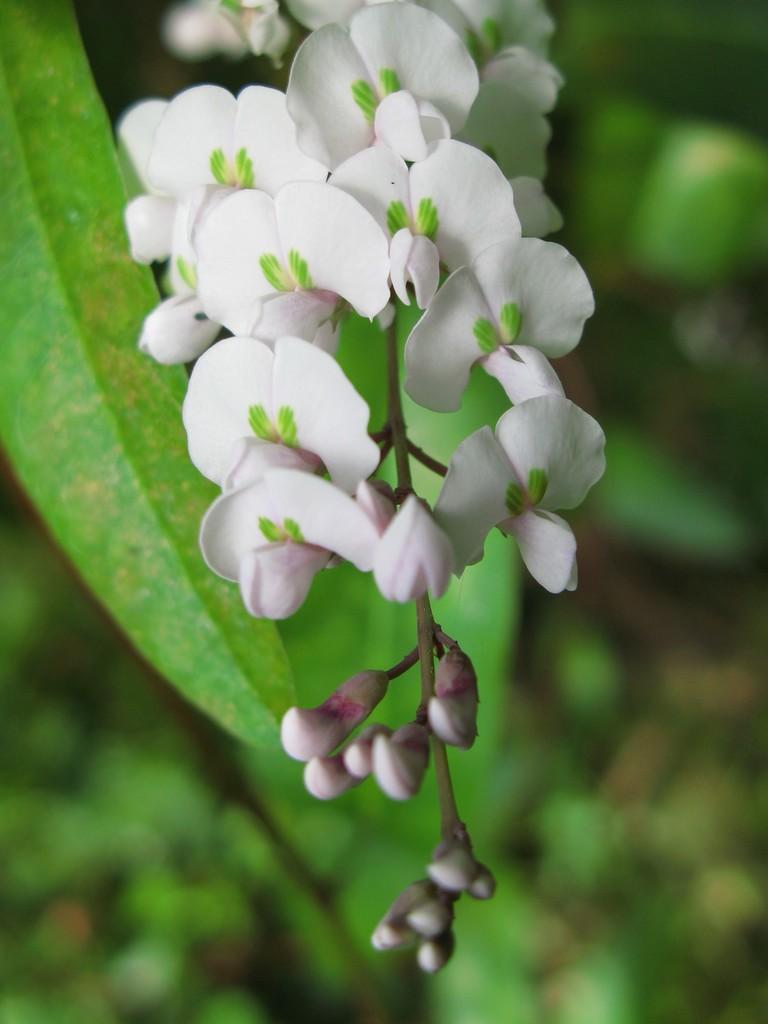Can you describe this image briefly? In this image there are flowers and buds to a stem. Behind it there are leaves. The background is blurry. 